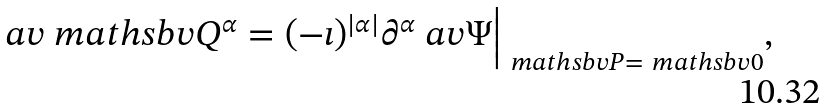<formula> <loc_0><loc_0><loc_500><loc_500>\ a v { \ m a t h s b v { Q } ^ { \alpha } } = ( - \imath ) ^ { | \alpha | } \partial ^ { \alpha } \ a v { \Psi } \Big | _ { \ m a t h s b v { P } = \ m a t h s b v { 0 } } ,</formula> 